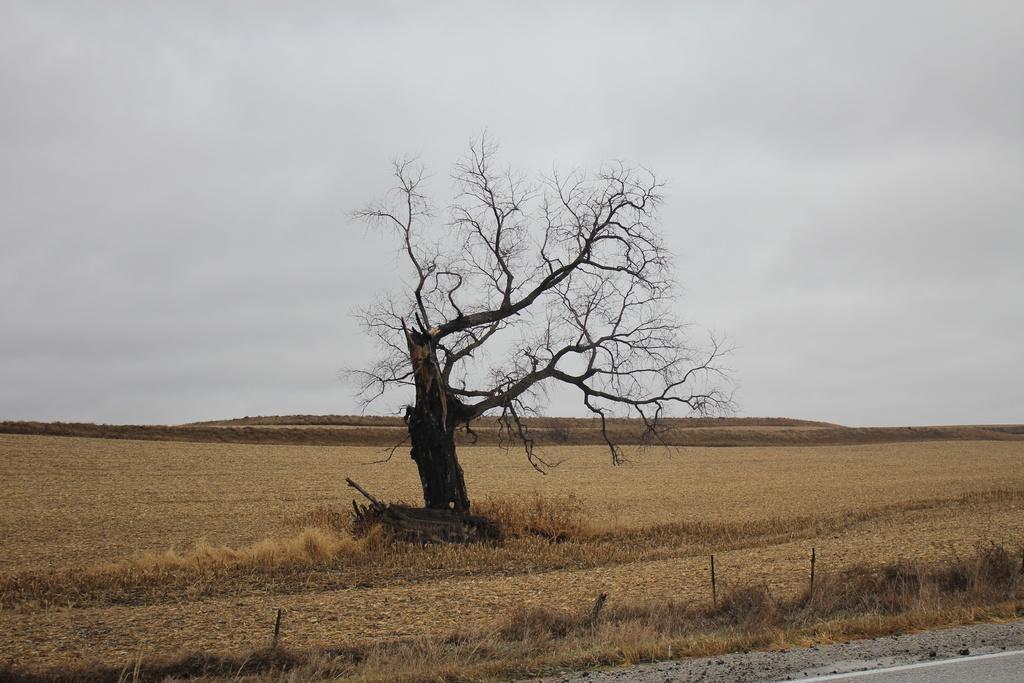Please provide a concise description of this image. At the bottom of the image on the ground there is grass. And also there is a tree without leaves. At the top of the image there is sky. 